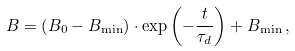<formula> <loc_0><loc_0><loc_500><loc_500>B = \left ( B _ { 0 } - B _ { \min } \right ) \cdot \exp \left ( - \frac { t } { \tau _ { d } } \right ) + B _ { \min } \, ,</formula> 